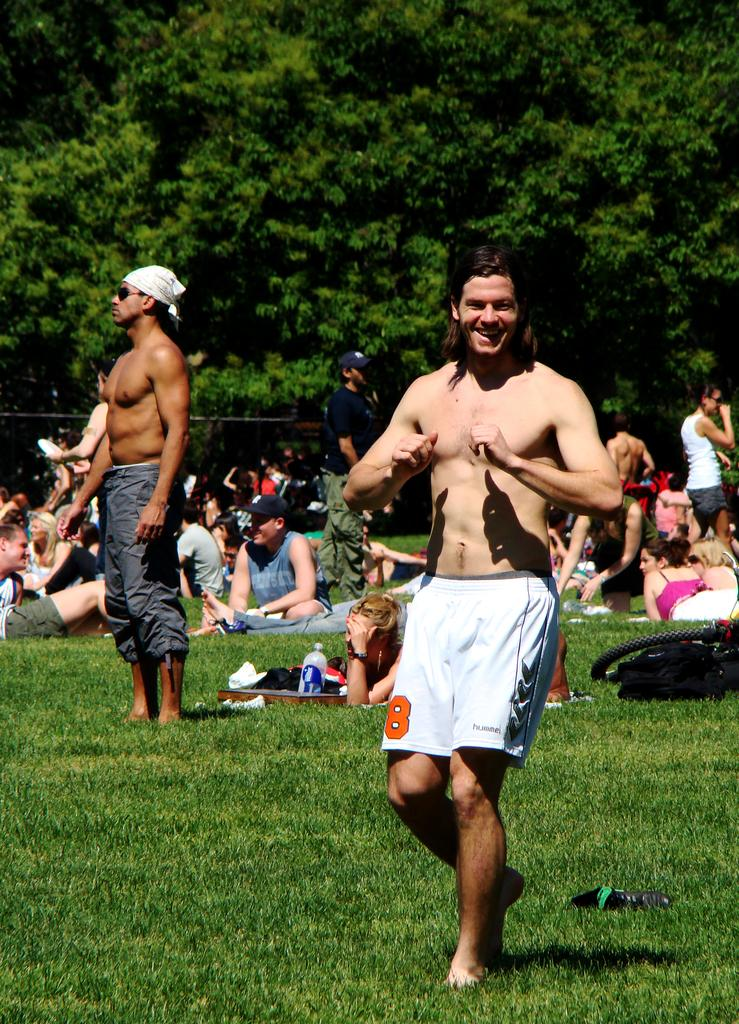<image>
Describe the image concisely. A man wearing Hummel shorts is playing at a park where people are laying on blankets and relaxing. 